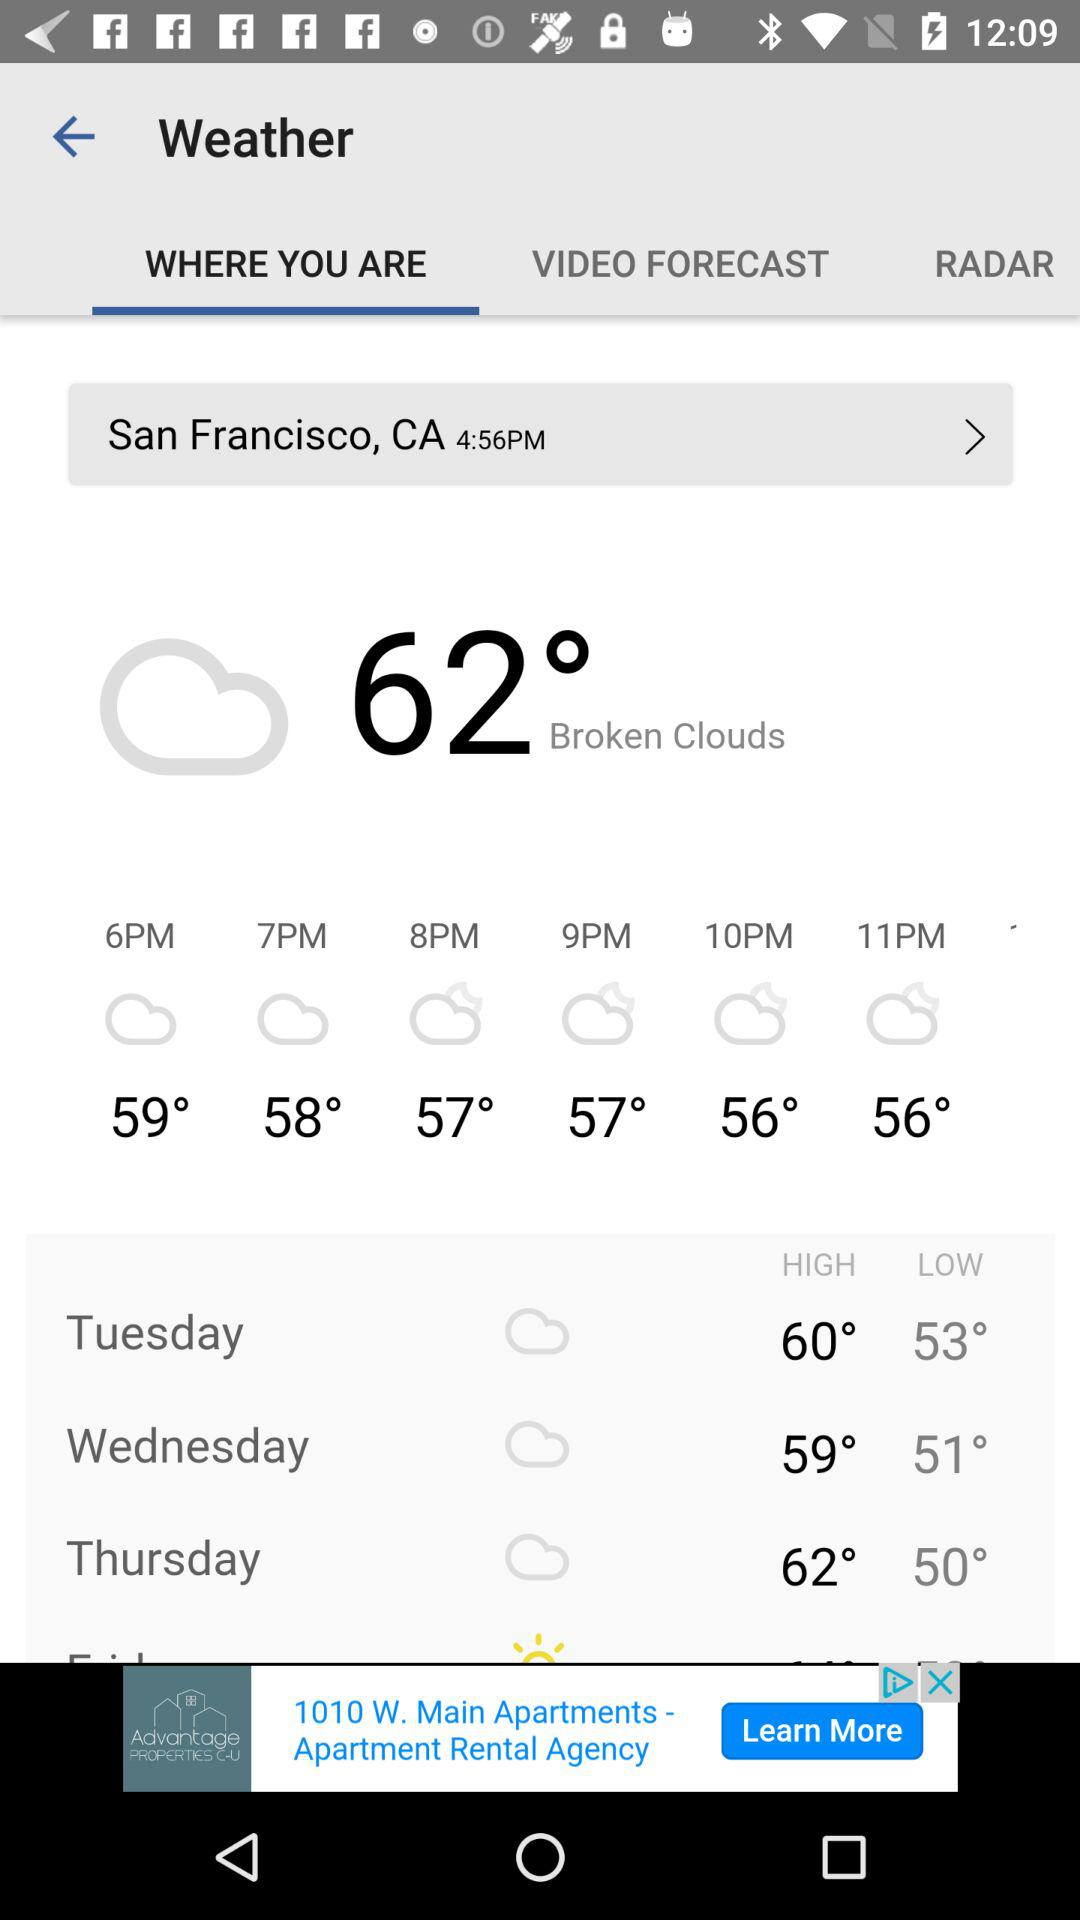What was the temperature at 6 pm? The temperature at 6 pm was 59°. 